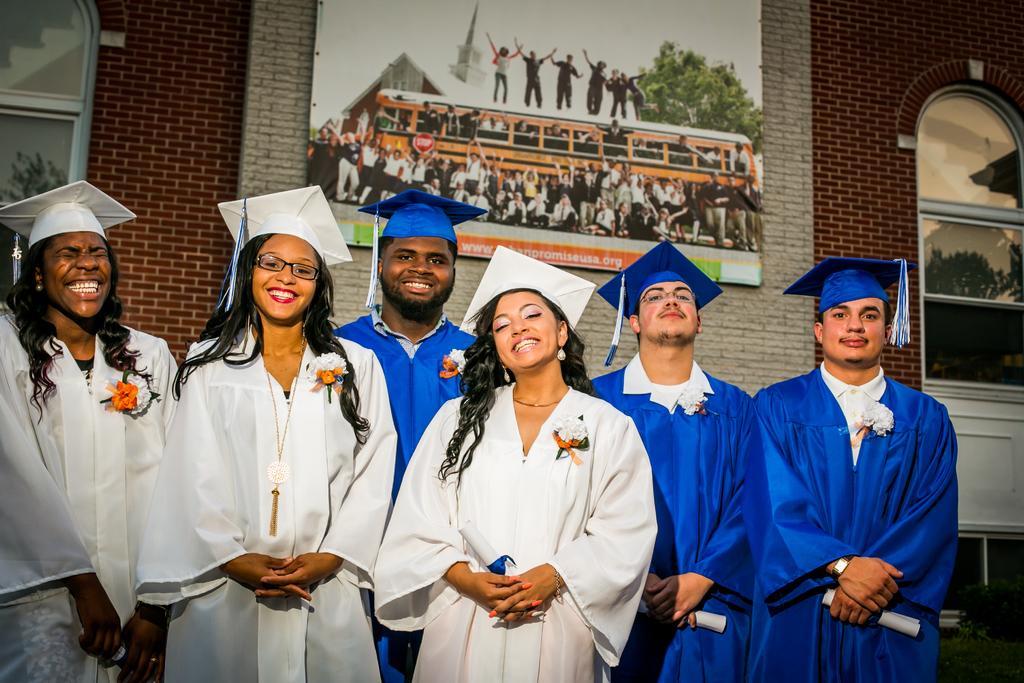Could you give a brief overview of what you see in this image? In this image we can see there are a few people standing and smiling. In the background of the image there is a wall with red and white bricks and there is a photo frame attached to the wall. In that photo frame there are a few people standing in front of the bus and some people are standing up on the bus. 